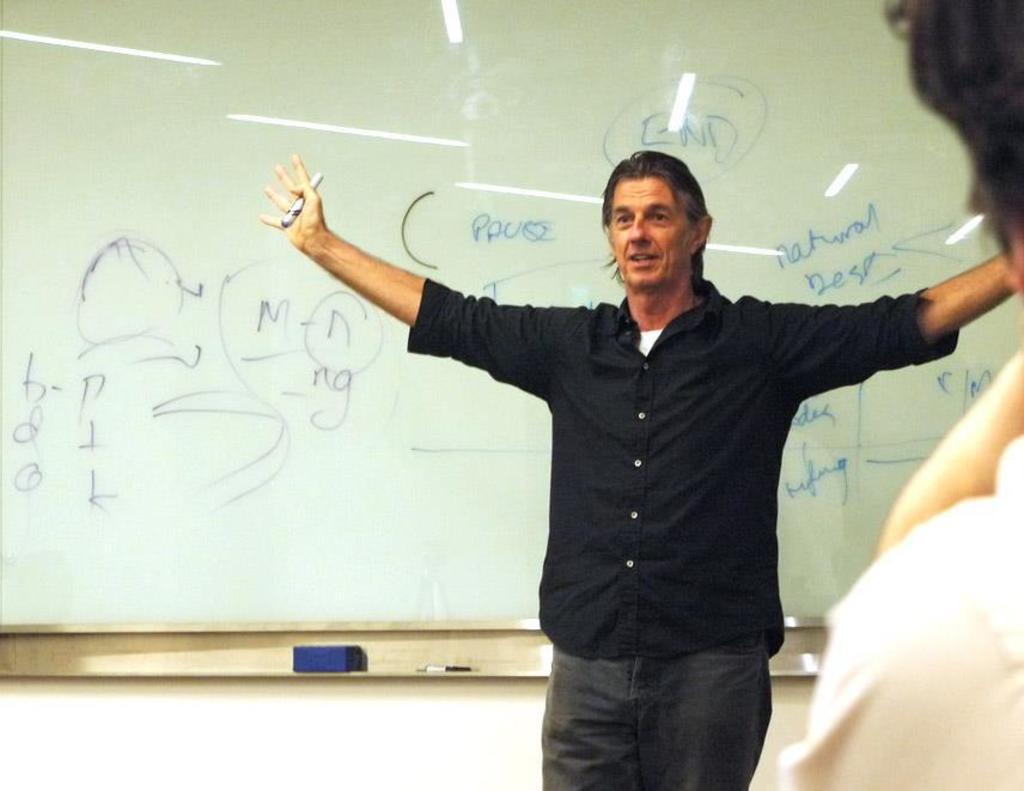What word  is located above the speakers head?
Provide a short and direct response. End. What is the word to the left of the speakers head?
Keep it short and to the point. Pause. 